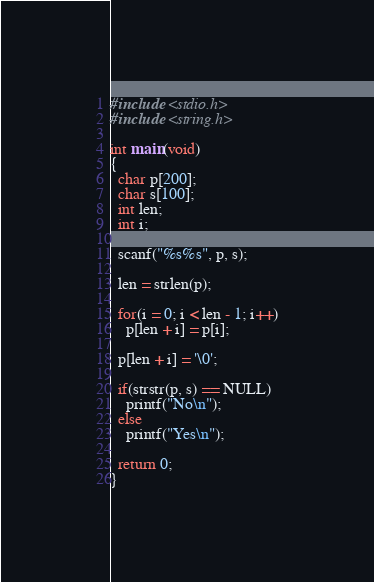Convert code to text. <code><loc_0><loc_0><loc_500><loc_500><_C_>#include <stdio.h>
#include <string.h>

int main(void)
{
  char p[200];
  char s[100];
  int len;
  int i;

  scanf("%s%s", p, s);

  len = strlen(p);

  for(i = 0; i < len - 1; i++)
    p[len + i] = p[i];

  p[len + i] = '\0';
  
  if(strstr(p, s) == NULL)
    printf("No\n");
  else
    printf("Yes\n");

  return 0;
}</code> 